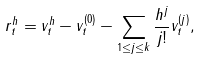Convert formula to latex. <formula><loc_0><loc_0><loc_500><loc_500>r ^ { h } _ { t } = v ^ { h } _ { t } - v ^ { ( 0 ) } _ { t } - \sum _ { 1 \leq j \leq k } \frac { h ^ { j } } { j ! } v ^ { ( j ) } _ { t } ,</formula> 